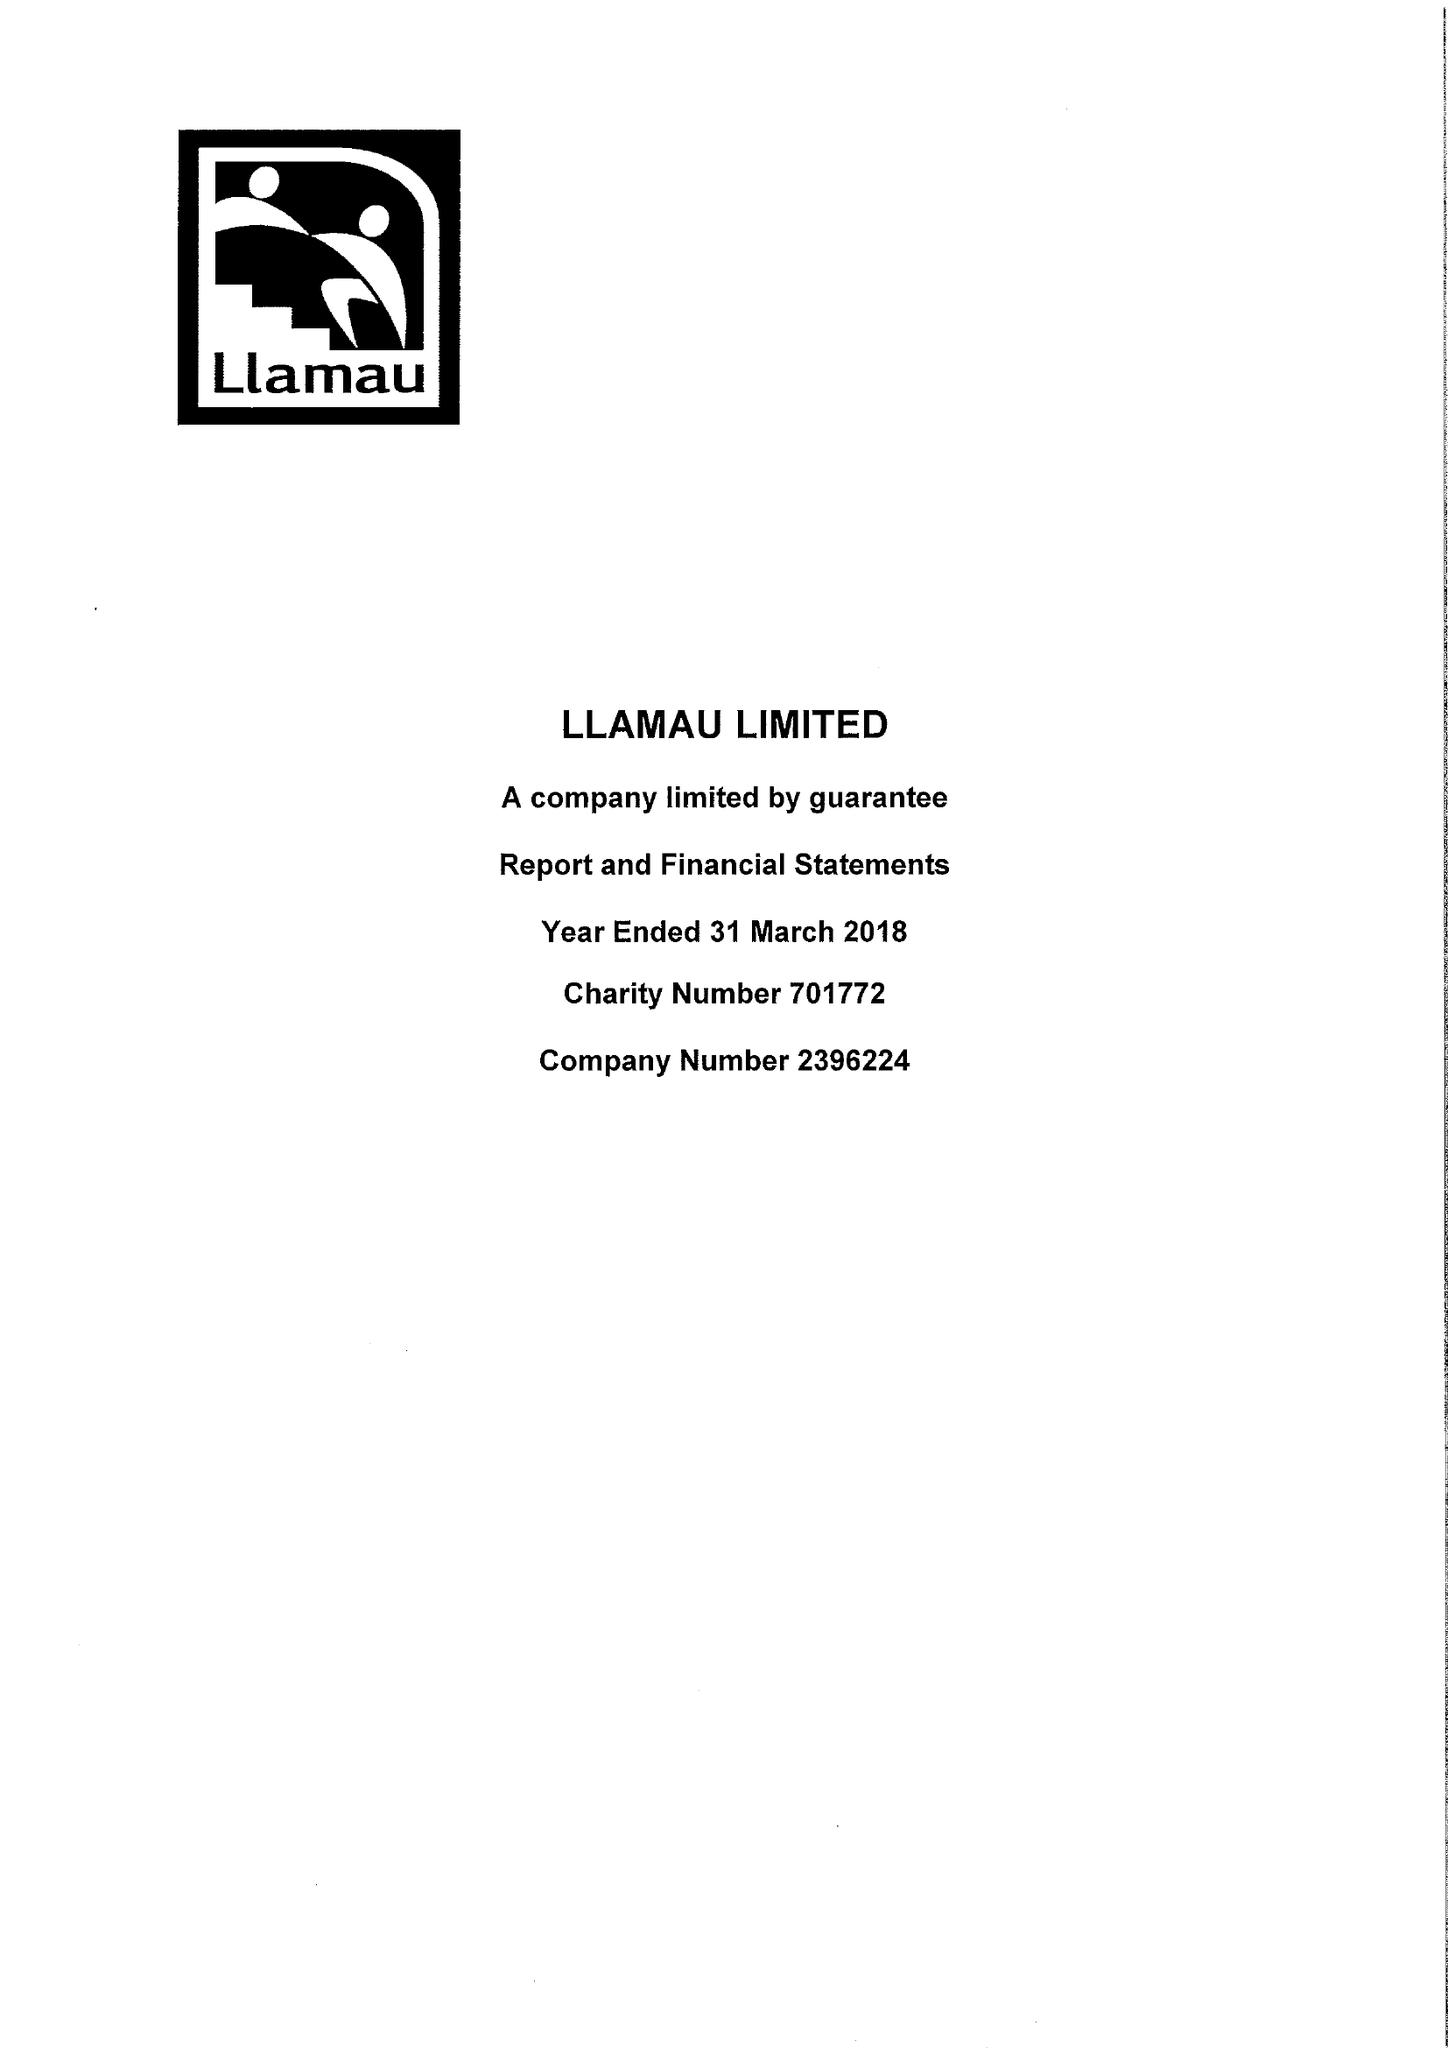What is the value for the spending_annually_in_british_pounds?
Answer the question using a single word or phrase. 9525575.00 